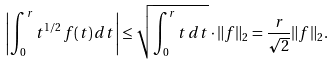Convert formula to latex. <formula><loc_0><loc_0><loc_500><loc_500>\left | \int _ { 0 } ^ { r } t ^ { 1 / 2 } \, f ( t ) \, d t \right | \leq \sqrt { \int _ { 0 } ^ { r } t \, d t } \cdot \| f \| _ { 2 } = \frac { r } { \sqrt { 2 } } \| f \| _ { 2 } .</formula> 